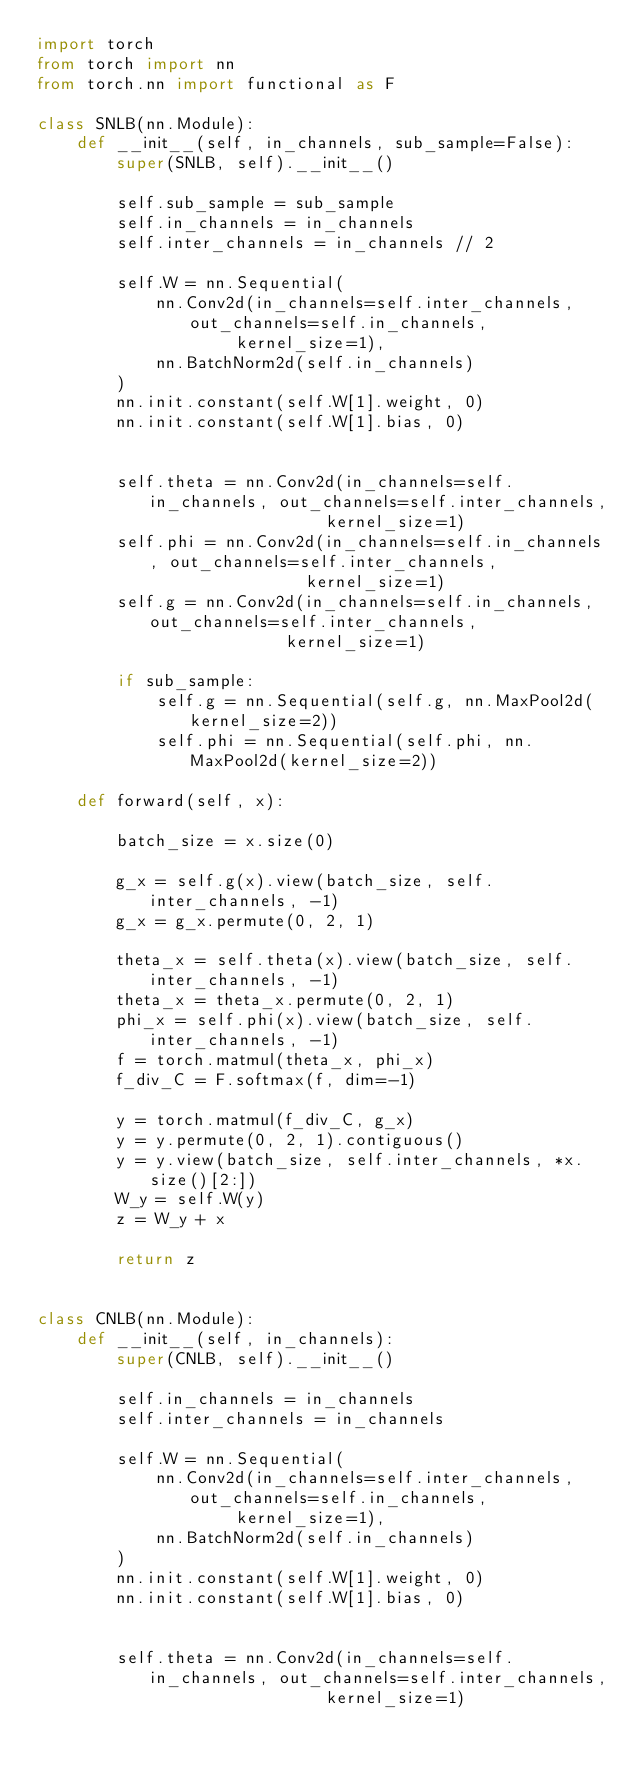<code> <loc_0><loc_0><loc_500><loc_500><_Python_>import torch
from torch import nn
from torch.nn import functional as F

class SNLB(nn.Module):
    def __init__(self, in_channels, sub_sample=False):
        super(SNLB, self).__init__()

        self.sub_sample = sub_sample
        self.in_channels = in_channels
        self.inter_channels = in_channels // 2

        self.W = nn.Sequential(
            nn.Conv2d(in_channels=self.inter_channels, out_channels=self.in_channels,
                    kernel_size=1),
            nn.BatchNorm2d(self.in_channels)
        )
        nn.init.constant(self.W[1].weight, 0)
        nn.init.constant(self.W[1].bias, 0)


        self.theta = nn.Conv2d(in_channels=self.in_channels, out_channels=self.inter_channels,
                             kernel_size=1)
        self.phi = nn.Conv2d(in_channels=self.in_channels, out_channels=self.inter_channels,
                           kernel_size=1)
        self.g = nn.Conv2d(in_channels=self.in_channels, out_channels=self.inter_channels,
                         kernel_size=1)

        if sub_sample:
            self.g = nn.Sequential(self.g, nn.MaxPool2d(kernel_size=2))
            self.phi = nn.Sequential(self.phi, nn.MaxPool2d(kernel_size=2))

    def forward(self, x):

        batch_size = x.size(0)

        g_x = self.g(x).view(batch_size, self.inter_channels, -1)
        g_x = g_x.permute(0, 2, 1)

        theta_x = self.theta(x).view(batch_size, self.inter_channels, -1)
        theta_x = theta_x.permute(0, 2, 1)
        phi_x = self.phi(x).view(batch_size, self.inter_channels, -1)
        f = torch.matmul(theta_x, phi_x)
        f_div_C = F.softmax(f, dim=-1)

        y = torch.matmul(f_div_C, g_x)
        y = y.permute(0, 2, 1).contiguous()
        y = y.view(batch_size, self.inter_channels, *x.size()[2:])
        W_y = self.W(y)
        z = W_y + x

        return z


class CNLB(nn.Module):
    def __init__(self, in_channels):
        super(CNLB, self).__init__()

        self.in_channels = in_channels
        self.inter_channels = in_channels

        self.W = nn.Sequential(
            nn.Conv2d(in_channels=self.inter_channels, out_channels=self.in_channels,
                    kernel_size=1),
            nn.BatchNorm2d(self.in_channels)
        )
        nn.init.constant(self.W[1].weight, 0)
        nn.init.constant(self.W[1].bias, 0)


        self.theta = nn.Conv2d(in_channels=self.in_channels, out_channels=self.inter_channels,
                             kernel_size=1)</code> 